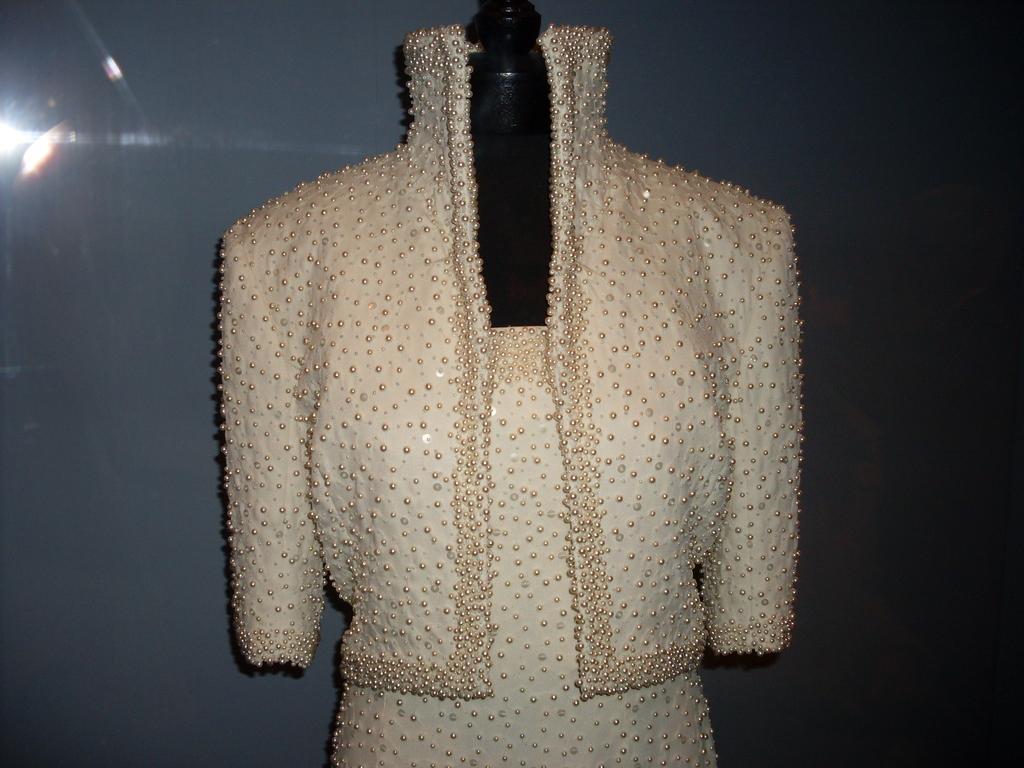Could you give a brief overview of what you see in this image? In this image we can see a dress on a mannequin. On the backside we can see a wall. 